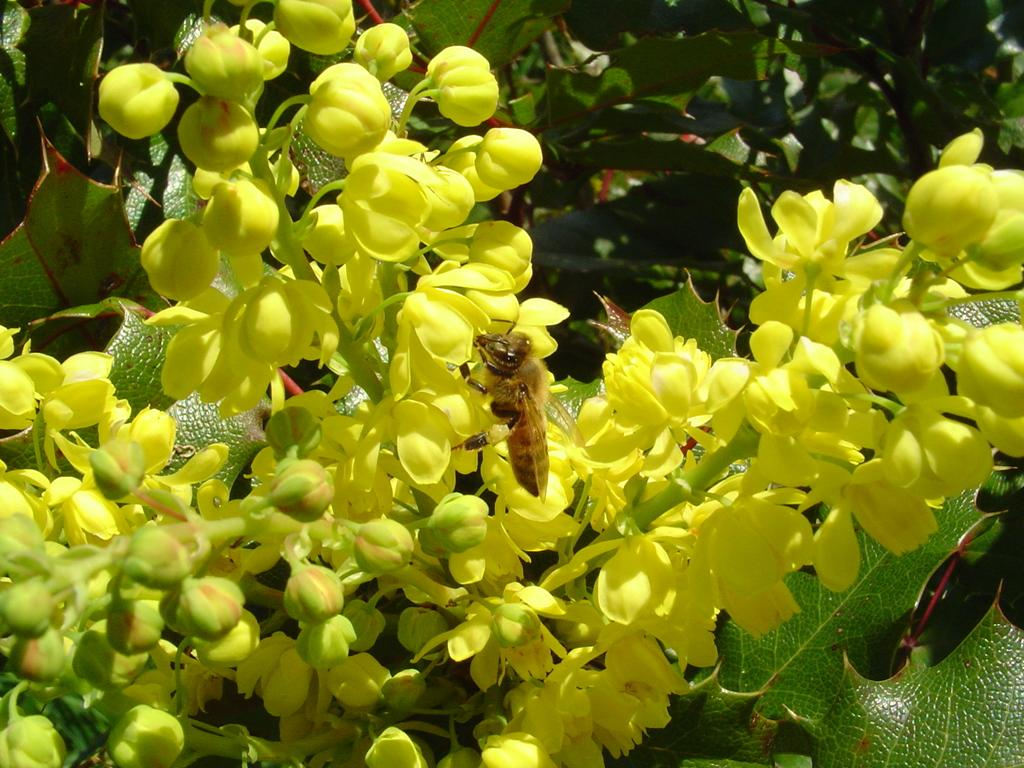What is on the flower in the image? There is an insect on a flower in the image. What else can be seen in the image besides the insect? There is a bunch of flowers in the image. What is the growth stage of some of the flowers in the image? There are buds on a plant in the image. What texture does the man's shirt have in the image? There is no man present in the image, so we cannot determine the texture of any shirt. 